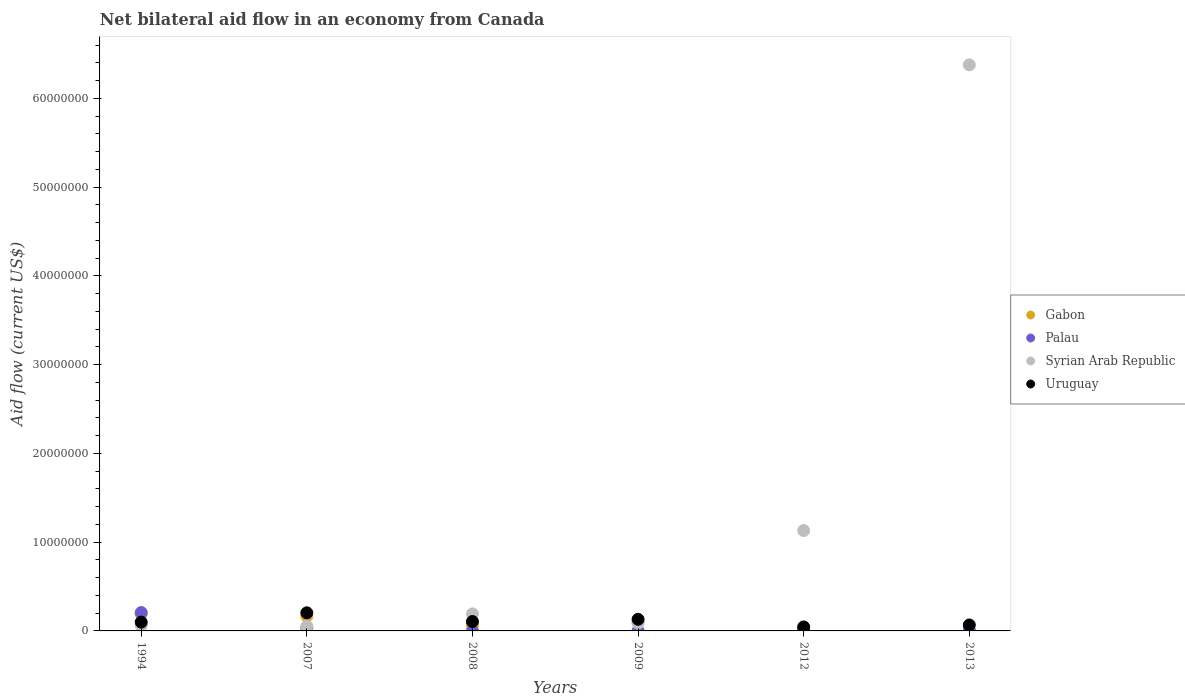How many different coloured dotlines are there?
Provide a succinct answer. 4. Is the number of dotlines equal to the number of legend labels?
Make the answer very short. Yes. What is the net bilateral aid flow in Gabon in 1994?
Your answer should be compact. 1.94e+06. Across all years, what is the maximum net bilateral aid flow in Palau?
Offer a very short reply. 2.07e+06. In which year was the net bilateral aid flow in Gabon maximum?
Offer a terse response. 1994. What is the total net bilateral aid flow in Gabon in the graph?
Offer a very short reply. 5.35e+06. What is the difference between the net bilateral aid flow in Syrian Arab Republic in 2009 and that in 2012?
Keep it short and to the point. -1.04e+07. What is the difference between the net bilateral aid flow in Palau in 1994 and the net bilateral aid flow in Uruguay in 2013?
Offer a very short reply. 1.40e+06. What is the average net bilateral aid flow in Gabon per year?
Your answer should be compact. 8.92e+05. In the year 2007, what is the difference between the net bilateral aid flow in Palau and net bilateral aid flow in Gabon?
Keep it short and to the point. -1.32e+06. What is the ratio of the net bilateral aid flow in Palau in 1994 to that in 2013?
Your response must be concise. 41.4. Is the net bilateral aid flow in Syrian Arab Republic in 1994 less than that in 2009?
Your response must be concise. Yes. Is the difference between the net bilateral aid flow in Palau in 1994 and 2009 greater than the difference between the net bilateral aid flow in Gabon in 1994 and 2009?
Your answer should be compact. Yes. What is the difference between the highest and the second highest net bilateral aid flow in Palau?
Give a very brief answer. 1.73e+06. What is the difference between the highest and the lowest net bilateral aid flow in Syrian Arab Republic?
Make the answer very short. 6.33e+07. Is it the case that in every year, the sum of the net bilateral aid flow in Gabon and net bilateral aid flow in Uruguay  is greater than the sum of net bilateral aid flow in Syrian Arab Republic and net bilateral aid flow in Palau?
Offer a very short reply. No. Does the net bilateral aid flow in Uruguay monotonically increase over the years?
Keep it short and to the point. No. Is the net bilateral aid flow in Syrian Arab Republic strictly greater than the net bilateral aid flow in Gabon over the years?
Offer a very short reply. No. How many dotlines are there?
Make the answer very short. 4. How many years are there in the graph?
Your answer should be very brief. 6. Are the values on the major ticks of Y-axis written in scientific E-notation?
Provide a short and direct response. No. Does the graph contain any zero values?
Your answer should be very brief. No. Where does the legend appear in the graph?
Your response must be concise. Center right. How are the legend labels stacked?
Your answer should be very brief. Vertical. What is the title of the graph?
Ensure brevity in your answer.  Net bilateral aid flow in an economy from Canada. What is the label or title of the Y-axis?
Your answer should be compact. Aid flow (current US$). What is the Aid flow (current US$) in Gabon in 1994?
Keep it short and to the point. 1.94e+06. What is the Aid flow (current US$) in Palau in 1994?
Give a very brief answer. 2.07e+06. What is the Aid flow (current US$) of Syrian Arab Republic in 1994?
Your answer should be compact. 6.20e+05. What is the Aid flow (current US$) in Uruguay in 1994?
Offer a very short reply. 9.90e+05. What is the Aid flow (current US$) of Gabon in 2007?
Provide a succinct answer. 1.66e+06. What is the Aid flow (current US$) in Palau in 2007?
Ensure brevity in your answer.  3.40e+05. What is the Aid flow (current US$) in Syrian Arab Republic in 2007?
Your answer should be very brief. 5.20e+05. What is the Aid flow (current US$) in Uruguay in 2007?
Provide a succinct answer. 2.04e+06. What is the Aid flow (current US$) in Gabon in 2008?
Your answer should be compact. 6.50e+05. What is the Aid flow (current US$) in Palau in 2008?
Your response must be concise. 10000. What is the Aid flow (current US$) of Syrian Arab Republic in 2008?
Your response must be concise. 1.92e+06. What is the Aid flow (current US$) in Uruguay in 2008?
Offer a terse response. 1.06e+06. What is the Aid flow (current US$) of Gabon in 2009?
Offer a very short reply. 9.80e+05. What is the Aid flow (current US$) in Palau in 2009?
Provide a short and direct response. 10000. What is the Aid flow (current US$) of Syrian Arab Republic in 2009?
Offer a very short reply. 8.70e+05. What is the Aid flow (current US$) in Uruguay in 2009?
Keep it short and to the point. 1.31e+06. What is the Aid flow (current US$) of Gabon in 2012?
Provide a short and direct response. 5.00e+04. What is the Aid flow (current US$) in Syrian Arab Republic in 2012?
Keep it short and to the point. 1.13e+07. What is the Aid flow (current US$) of Syrian Arab Republic in 2013?
Provide a succinct answer. 6.38e+07. What is the Aid flow (current US$) of Uruguay in 2013?
Your answer should be compact. 6.70e+05. Across all years, what is the maximum Aid flow (current US$) in Gabon?
Provide a short and direct response. 1.94e+06. Across all years, what is the maximum Aid flow (current US$) of Palau?
Offer a very short reply. 2.07e+06. Across all years, what is the maximum Aid flow (current US$) in Syrian Arab Republic?
Your answer should be very brief. 6.38e+07. Across all years, what is the maximum Aid flow (current US$) in Uruguay?
Your answer should be very brief. 2.04e+06. Across all years, what is the minimum Aid flow (current US$) of Gabon?
Your answer should be compact. 5.00e+04. Across all years, what is the minimum Aid flow (current US$) in Syrian Arab Republic?
Your answer should be very brief. 5.20e+05. Across all years, what is the minimum Aid flow (current US$) of Uruguay?
Your response must be concise. 4.50e+05. What is the total Aid flow (current US$) of Gabon in the graph?
Provide a short and direct response. 5.35e+06. What is the total Aid flow (current US$) of Palau in the graph?
Give a very brief answer. 2.65e+06. What is the total Aid flow (current US$) in Syrian Arab Republic in the graph?
Make the answer very short. 7.90e+07. What is the total Aid flow (current US$) in Uruguay in the graph?
Provide a succinct answer. 6.52e+06. What is the difference between the Aid flow (current US$) of Palau in 1994 and that in 2007?
Give a very brief answer. 1.73e+06. What is the difference between the Aid flow (current US$) in Uruguay in 1994 and that in 2007?
Provide a short and direct response. -1.05e+06. What is the difference between the Aid flow (current US$) in Gabon in 1994 and that in 2008?
Keep it short and to the point. 1.29e+06. What is the difference between the Aid flow (current US$) in Palau in 1994 and that in 2008?
Your response must be concise. 2.06e+06. What is the difference between the Aid flow (current US$) in Syrian Arab Republic in 1994 and that in 2008?
Your answer should be compact. -1.30e+06. What is the difference between the Aid flow (current US$) in Gabon in 1994 and that in 2009?
Give a very brief answer. 9.60e+05. What is the difference between the Aid flow (current US$) of Palau in 1994 and that in 2009?
Your answer should be compact. 2.06e+06. What is the difference between the Aid flow (current US$) in Uruguay in 1994 and that in 2009?
Your answer should be compact. -3.20e+05. What is the difference between the Aid flow (current US$) of Gabon in 1994 and that in 2012?
Offer a very short reply. 1.89e+06. What is the difference between the Aid flow (current US$) of Palau in 1994 and that in 2012?
Ensure brevity in your answer.  1.90e+06. What is the difference between the Aid flow (current US$) of Syrian Arab Republic in 1994 and that in 2012?
Keep it short and to the point. -1.07e+07. What is the difference between the Aid flow (current US$) in Uruguay in 1994 and that in 2012?
Ensure brevity in your answer.  5.40e+05. What is the difference between the Aid flow (current US$) in Gabon in 1994 and that in 2013?
Your response must be concise. 1.87e+06. What is the difference between the Aid flow (current US$) of Palau in 1994 and that in 2013?
Offer a terse response. 2.02e+06. What is the difference between the Aid flow (current US$) of Syrian Arab Republic in 1994 and that in 2013?
Offer a very short reply. -6.32e+07. What is the difference between the Aid flow (current US$) in Uruguay in 1994 and that in 2013?
Your answer should be compact. 3.20e+05. What is the difference between the Aid flow (current US$) in Gabon in 2007 and that in 2008?
Your answer should be very brief. 1.01e+06. What is the difference between the Aid flow (current US$) in Palau in 2007 and that in 2008?
Offer a very short reply. 3.30e+05. What is the difference between the Aid flow (current US$) in Syrian Arab Republic in 2007 and that in 2008?
Give a very brief answer. -1.40e+06. What is the difference between the Aid flow (current US$) in Uruguay in 2007 and that in 2008?
Make the answer very short. 9.80e+05. What is the difference between the Aid flow (current US$) in Gabon in 2007 and that in 2009?
Ensure brevity in your answer.  6.80e+05. What is the difference between the Aid flow (current US$) of Palau in 2007 and that in 2009?
Ensure brevity in your answer.  3.30e+05. What is the difference between the Aid flow (current US$) in Syrian Arab Republic in 2007 and that in 2009?
Your response must be concise. -3.50e+05. What is the difference between the Aid flow (current US$) of Uruguay in 2007 and that in 2009?
Your response must be concise. 7.30e+05. What is the difference between the Aid flow (current US$) in Gabon in 2007 and that in 2012?
Your response must be concise. 1.61e+06. What is the difference between the Aid flow (current US$) in Syrian Arab Republic in 2007 and that in 2012?
Give a very brief answer. -1.08e+07. What is the difference between the Aid flow (current US$) in Uruguay in 2007 and that in 2012?
Your response must be concise. 1.59e+06. What is the difference between the Aid flow (current US$) of Gabon in 2007 and that in 2013?
Provide a short and direct response. 1.59e+06. What is the difference between the Aid flow (current US$) of Palau in 2007 and that in 2013?
Provide a succinct answer. 2.90e+05. What is the difference between the Aid flow (current US$) in Syrian Arab Republic in 2007 and that in 2013?
Keep it short and to the point. -6.33e+07. What is the difference between the Aid flow (current US$) of Uruguay in 2007 and that in 2013?
Offer a very short reply. 1.37e+06. What is the difference between the Aid flow (current US$) of Gabon in 2008 and that in 2009?
Your answer should be compact. -3.30e+05. What is the difference between the Aid flow (current US$) in Syrian Arab Republic in 2008 and that in 2009?
Provide a short and direct response. 1.05e+06. What is the difference between the Aid flow (current US$) in Uruguay in 2008 and that in 2009?
Keep it short and to the point. -2.50e+05. What is the difference between the Aid flow (current US$) of Gabon in 2008 and that in 2012?
Give a very brief answer. 6.00e+05. What is the difference between the Aid flow (current US$) in Syrian Arab Republic in 2008 and that in 2012?
Offer a very short reply. -9.39e+06. What is the difference between the Aid flow (current US$) of Gabon in 2008 and that in 2013?
Your answer should be very brief. 5.80e+05. What is the difference between the Aid flow (current US$) in Syrian Arab Republic in 2008 and that in 2013?
Your response must be concise. -6.19e+07. What is the difference between the Aid flow (current US$) in Uruguay in 2008 and that in 2013?
Ensure brevity in your answer.  3.90e+05. What is the difference between the Aid flow (current US$) in Gabon in 2009 and that in 2012?
Your response must be concise. 9.30e+05. What is the difference between the Aid flow (current US$) in Palau in 2009 and that in 2012?
Offer a very short reply. -1.60e+05. What is the difference between the Aid flow (current US$) of Syrian Arab Republic in 2009 and that in 2012?
Give a very brief answer. -1.04e+07. What is the difference between the Aid flow (current US$) of Uruguay in 2009 and that in 2012?
Provide a succinct answer. 8.60e+05. What is the difference between the Aid flow (current US$) in Gabon in 2009 and that in 2013?
Offer a very short reply. 9.10e+05. What is the difference between the Aid flow (current US$) in Syrian Arab Republic in 2009 and that in 2013?
Your answer should be compact. -6.29e+07. What is the difference between the Aid flow (current US$) of Uruguay in 2009 and that in 2013?
Offer a very short reply. 6.40e+05. What is the difference between the Aid flow (current US$) in Syrian Arab Republic in 2012 and that in 2013?
Provide a short and direct response. -5.25e+07. What is the difference between the Aid flow (current US$) in Uruguay in 2012 and that in 2013?
Your answer should be very brief. -2.20e+05. What is the difference between the Aid flow (current US$) of Gabon in 1994 and the Aid flow (current US$) of Palau in 2007?
Your answer should be very brief. 1.60e+06. What is the difference between the Aid flow (current US$) in Gabon in 1994 and the Aid flow (current US$) in Syrian Arab Republic in 2007?
Offer a very short reply. 1.42e+06. What is the difference between the Aid flow (current US$) in Palau in 1994 and the Aid flow (current US$) in Syrian Arab Republic in 2007?
Offer a very short reply. 1.55e+06. What is the difference between the Aid flow (current US$) of Syrian Arab Republic in 1994 and the Aid flow (current US$) of Uruguay in 2007?
Provide a succinct answer. -1.42e+06. What is the difference between the Aid flow (current US$) of Gabon in 1994 and the Aid flow (current US$) of Palau in 2008?
Give a very brief answer. 1.93e+06. What is the difference between the Aid flow (current US$) in Gabon in 1994 and the Aid flow (current US$) in Syrian Arab Republic in 2008?
Make the answer very short. 2.00e+04. What is the difference between the Aid flow (current US$) in Gabon in 1994 and the Aid flow (current US$) in Uruguay in 2008?
Your response must be concise. 8.80e+05. What is the difference between the Aid flow (current US$) of Palau in 1994 and the Aid flow (current US$) of Uruguay in 2008?
Your response must be concise. 1.01e+06. What is the difference between the Aid flow (current US$) of Syrian Arab Republic in 1994 and the Aid flow (current US$) of Uruguay in 2008?
Give a very brief answer. -4.40e+05. What is the difference between the Aid flow (current US$) in Gabon in 1994 and the Aid flow (current US$) in Palau in 2009?
Your answer should be very brief. 1.93e+06. What is the difference between the Aid flow (current US$) of Gabon in 1994 and the Aid flow (current US$) of Syrian Arab Republic in 2009?
Your answer should be compact. 1.07e+06. What is the difference between the Aid flow (current US$) of Gabon in 1994 and the Aid flow (current US$) of Uruguay in 2009?
Keep it short and to the point. 6.30e+05. What is the difference between the Aid flow (current US$) in Palau in 1994 and the Aid flow (current US$) in Syrian Arab Republic in 2009?
Keep it short and to the point. 1.20e+06. What is the difference between the Aid flow (current US$) in Palau in 1994 and the Aid flow (current US$) in Uruguay in 2009?
Your answer should be very brief. 7.60e+05. What is the difference between the Aid flow (current US$) in Syrian Arab Republic in 1994 and the Aid flow (current US$) in Uruguay in 2009?
Make the answer very short. -6.90e+05. What is the difference between the Aid flow (current US$) of Gabon in 1994 and the Aid flow (current US$) of Palau in 2012?
Provide a succinct answer. 1.77e+06. What is the difference between the Aid flow (current US$) of Gabon in 1994 and the Aid flow (current US$) of Syrian Arab Republic in 2012?
Offer a terse response. -9.37e+06. What is the difference between the Aid flow (current US$) in Gabon in 1994 and the Aid flow (current US$) in Uruguay in 2012?
Make the answer very short. 1.49e+06. What is the difference between the Aid flow (current US$) in Palau in 1994 and the Aid flow (current US$) in Syrian Arab Republic in 2012?
Make the answer very short. -9.24e+06. What is the difference between the Aid flow (current US$) in Palau in 1994 and the Aid flow (current US$) in Uruguay in 2012?
Provide a succinct answer. 1.62e+06. What is the difference between the Aid flow (current US$) of Gabon in 1994 and the Aid flow (current US$) of Palau in 2013?
Ensure brevity in your answer.  1.89e+06. What is the difference between the Aid flow (current US$) in Gabon in 1994 and the Aid flow (current US$) in Syrian Arab Republic in 2013?
Your answer should be very brief. -6.18e+07. What is the difference between the Aid flow (current US$) of Gabon in 1994 and the Aid flow (current US$) of Uruguay in 2013?
Keep it short and to the point. 1.27e+06. What is the difference between the Aid flow (current US$) of Palau in 1994 and the Aid flow (current US$) of Syrian Arab Republic in 2013?
Offer a terse response. -6.17e+07. What is the difference between the Aid flow (current US$) of Palau in 1994 and the Aid flow (current US$) of Uruguay in 2013?
Keep it short and to the point. 1.40e+06. What is the difference between the Aid flow (current US$) of Gabon in 2007 and the Aid flow (current US$) of Palau in 2008?
Your answer should be compact. 1.65e+06. What is the difference between the Aid flow (current US$) in Gabon in 2007 and the Aid flow (current US$) in Syrian Arab Republic in 2008?
Your response must be concise. -2.60e+05. What is the difference between the Aid flow (current US$) in Palau in 2007 and the Aid flow (current US$) in Syrian Arab Republic in 2008?
Offer a very short reply. -1.58e+06. What is the difference between the Aid flow (current US$) in Palau in 2007 and the Aid flow (current US$) in Uruguay in 2008?
Offer a very short reply. -7.20e+05. What is the difference between the Aid flow (current US$) in Syrian Arab Republic in 2007 and the Aid flow (current US$) in Uruguay in 2008?
Your answer should be very brief. -5.40e+05. What is the difference between the Aid flow (current US$) of Gabon in 2007 and the Aid flow (current US$) of Palau in 2009?
Provide a succinct answer. 1.65e+06. What is the difference between the Aid flow (current US$) of Gabon in 2007 and the Aid flow (current US$) of Syrian Arab Republic in 2009?
Provide a short and direct response. 7.90e+05. What is the difference between the Aid flow (current US$) in Gabon in 2007 and the Aid flow (current US$) in Uruguay in 2009?
Make the answer very short. 3.50e+05. What is the difference between the Aid flow (current US$) in Palau in 2007 and the Aid flow (current US$) in Syrian Arab Republic in 2009?
Provide a short and direct response. -5.30e+05. What is the difference between the Aid flow (current US$) of Palau in 2007 and the Aid flow (current US$) of Uruguay in 2009?
Give a very brief answer. -9.70e+05. What is the difference between the Aid flow (current US$) in Syrian Arab Republic in 2007 and the Aid flow (current US$) in Uruguay in 2009?
Make the answer very short. -7.90e+05. What is the difference between the Aid flow (current US$) of Gabon in 2007 and the Aid flow (current US$) of Palau in 2012?
Offer a very short reply. 1.49e+06. What is the difference between the Aid flow (current US$) of Gabon in 2007 and the Aid flow (current US$) of Syrian Arab Republic in 2012?
Give a very brief answer. -9.65e+06. What is the difference between the Aid flow (current US$) of Gabon in 2007 and the Aid flow (current US$) of Uruguay in 2012?
Ensure brevity in your answer.  1.21e+06. What is the difference between the Aid flow (current US$) of Palau in 2007 and the Aid flow (current US$) of Syrian Arab Republic in 2012?
Your response must be concise. -1.10e+07. What is the difference between the Aid flow (current US$) of Palau in 2007 and the Aid flow (current US$) of Uruguay in 2012?
Your answer should be very brief. -1.10e+05. What is the difference between the Aid flow (current US$) in Syrian Arab Republic in 2007 and the Aid flow (current US$) in Uruguay in 2012?
Ensure brevity in your answer.  7.00e+04. What is the difference between the Aid flow (current US$) of Gabon in 2007 and the Aid flow (current US$) of Palau in 2013?
Make the answer very short. 1.61e+06. What is the difference between the Aid flow (current US$) in Gabon in 2007 and the Aid flow (current US$) in Syrian Arab Republic in 2013?
Provide a succinct answer. -6.21e+07. What is the difference between the Aid flow (current US$) of Gabon in 2007 and the Aid flow (current US$) of Uruguay in 2013?
Provide a short and direct response. 9.90e+05. What is the difference between the Aid flow (current US$) in Palau in 2007 and the Aid flow (current US$) in Syrian Arab Republic in 2013?
Give a very brief answer. -6.34e+07. What is the difference between the Aid flow (current US$) of Palau in 2007 and the Aid flow (current US$) of Uruguay in 2013?
Ensure brevity in your answer.  -3.30e+05. What is the difference between the Aid flow (current US$) of Syrian Arab Republic in 2007 and the Aid flow (current US$) of Uruguay in 2013?
Give a very brief answer. -1.50e+05. What is the difference between the Aid flow (current US$) in Gabon in 2008 and the Aid flow (current US$) in Palau in 2009?
Your response must be concise. 6.40e+05. What is the difference between the Aid flow (current US$) in Gabon in 2008 and the Aid flow (current US$) in Uruguay in 2009?
Keep it short and to the point. -6.60e+05. What is the difference between the Aid flow (current US$) in Palau in 2008 and the Aid flow (current US$) in Syrian Arab Republic in 2009?
Keep it short and to the point. -8.60e+05. What is the difference between the Aid flow (current US$) in Palau in 2008 and the Aid flow (current US$) in Uruguay in 2009?
Ensure brevity in your answer.  -1.30e+06. What is the difference between the Aid flow (current US$) of Gabon in 2008 and the Aid flow (current US$) of Syrian Arab Republic in 2012?
Make the answer very short. -1.07e+07. What is the difference between the Aid flow (current US$) in Gabon in 2008 and the Aid flow (current US$) in Uruguay in 2012?
Your answer should be compact. 2.00e+05. What is the difference between the Aid flow (current US$) of Palau in 2008 and the Aid flow (current US$) of Syrian Arab Republic in 2012?
Make the answer very short. -1.13e+07. What is the difference between the Aid flow (current US$) in Palau in 2008 and the Aid flow (current US$) in Uruguay in 2012?
Provide a short and direct response. -4.40e+05. What is the difference between the Aid flow (current US$) in Syrian Arab Republic in 2008 and the Aid flow (current US$) in Uruguay in 2012?
Provide a short and direct response. 1.47e+06. What is the difference between the Aid flow (current US$) of Gabon in 2008 and the Aid flow (current US$) of Palau in 2013?
Your response must be concise. 6.00e+05. What is the difference between the Aid flow (current US$) of Gabon in 2008 and the Aid flow (current US$) of Syrian Arab Republic in 2013?
Your answer should be compact. -6.31e+07. What is the difference between the Aid flow (current US$) in Palau in 2008 and the Aid flow (current US$) in Syrian Arab Republic in 2013?
Keep it short and to the point. -6.38e+07. What is the difference between the Aid flow (current US$) of Palau in 2008 and the Aid flow (current US$) of Uruguay in 2013?
Your answer should be very brief. -6.60e+05. What is the difference between the Aid flow (current US$) of Syrian Arab Republic in 2008 and the Aid flow (current US$) of Uruguay in 2013?
Your answer should be compact. 1.25e+06. What is the difference between the Aid flow (current US$) in Gabon in 2009 and the Aid flow (current US$) in Palau in 2012?
Provide a short and direct response. 8.10e+05. What is the difference between the Aid flow (current US$) of Gabon in 2009 and the Aid flow (current US$) of Syrian Arab Republic in 2012?
Offer a very short reply. -1.03e+07. What is the difference between the Aid flow (current US$) of Gabon in 2009 and the Aid flow (current US$) of Uruguay in 2012?
Your answer should be compact. 5.30e+05. What is the difference between the Aid flow (current US$) of Palau in 2009 and the Aid flow (current US$) of Syrian Arab Republic in 2012?
Provide a short and direct response. -1.13e+07. What is the difference between the Aid flow (current US$) in Palau in 2009 and the Aid flow (current US$) in Uruguay in 2012?
Give a very brief answer. -4.40e+05. What is the difference between the Aid flow (current US$) of Syrian Arab Republic in 2009 and the Aid flow (current US$) of Uruguay in 2012?
Provide a short and direct response. 4.20e+05. What is the difference between the Aid flow (current US$) of Gabon in 2009 and the Aid flow (current US$) of Palau in 2013?
Provide a short and direct response. 9.30e+05. What is the difference between the Aid flow (current US$) of Gabon in 2009 and the Aid flow (current US$) of Syrian Arab Republic in 2013?
Your response must be concise. -6.28e+07. What is the difference between the Aid flow (current US$) in Gabon in 2009 and the Aid flow (current US$) in Uruguay in 2013?
Provide a succinct answer. 3.10e+05. What is the difference between the Aid flow (current US$) in Palau in 2009 and the Aid flow (current US$) in Syrian Arab Republic in 2013?
Your answer should be compact. -6.38e+07. What is the difference between the Aid flow (current US$) in Palau in 2009 and the Aid flow (current US$) in Uruguay in 2013?
Provide a short and direct response. -6.60e+05. What is the difference between the Aid flow (current US$) in Syrian Arab Republic in 2009 and the Aid flow (current US$) in Uruguay in 2013?
Give a very brief answer. 2.00e+05. What is the difference between the Aid flow (current US$) of Gabon in 2012 and the Aid flow (current US$) of Palau in 2013?
Keep it short and to the point. 0. What is the difference between the Aid flow (current US$) of Gabon in 2012 and the Aid flow (current US$) of Syrian Arab Republic in 2013?
Give a very brief answer. -6.37e+07. What is the difference between the Aid flow (current US$) of Gabon in 2012 and the Aid flow (current US$) of Uruguay in 2013?
Your answer should be very brief. -6.20e+05. What is the difference between the Aid flow (current US$) in Palau in 2012 and the Aid flow (current US$) in Syrian Arab Republic in 2013?
Your answer should be very brief. -6.36e+07. What is the difference between the Aid flow (current US$) in Palau in 2012 and the Aid flow (current US$) in Uruguay in 2013?
Offer a terse response. -5.00e+05. What is the difference between the Aid flow (current US$) in Syrian Arab Republic in 2012 and the Aid flow (current US$) in Uruguay in 2013?
Ensure brevity in your answer.  1.06e+07. What is the average Aid flow (current US$) in Gabon per year?
Keep it short and to the point. 8.92e+05. What is the average Aid flow (current US$) in Palau per year?
Your response must be concise. 4.42e+05. What is the average Aid flow (current US$) in Syrian Arab Republic per year?
Offer a very short reply. 1.32e+07. What is the average Aid flow (current US$) in Uruguay per year?
Give a very brief answer. 1.09e+06. In the year 1994, what is the difference between the Aid flow (current US$) of Gabon and Aid flow (current US$) of Syrian Arab Republic?
Your answer should be compact. 1.32e+06. In the year 1994, what is the difference between the Aid flow (current US$) in Gabon and Aid flow (current US$) in Uruguay?
Give a very brief answer. 9.50e+05. In the year 1994, what is the difference between the Aid flow (current US$) in Palau and Aid flow (current US$) in Syrian Arab Republic?
Provide a succinct answer. 1.45e+06. In the year 1994, what is the difference between the Aid flow (current US$) in Palau and Aid flow (current US$) in Uruguay?
Keep it short and to the point. 1.08e+06. In the year 1994, what is the difference between the Aid flow (current US$) in Syrian Arab Republic and Aid flow (current US$) in Uruguay?
Your answer should be compact. -3.70e+05. In the year 2007, what is the difference between the Aid flow (current US$) of Gabon and Aid flow (current US$) of Palau?
Offer a terse response. 1.32e+06. In the year 2007, what is the difference between the Aid flow (current US$) in Gabon and Aid flow (current US$) in Syrian Arab Republic?
Make the answer very short. 1.14e+06. In the year 2007, what is the difference between the Aid flow (current US$) of Gabon and Aid flow (current US$) of Uruguay?
Ensure brevity in your answer.  -3.80e+05. In the year 2007, what is the difference between the Aid flow (current US$) of Palau and Aid flow (current US$) of Uruguay?
Ensure brevity in your answer.  -1.70e+06. In the year 2007, what is the difference between the Aid flow (current US$) of Syrian Arab Republic and Aid flow (current US$) of Uruguay?
Offer a very short reply. -1.52e+06. In the year 2008, what is the difference between the Aid flow (current US$) of Gabon and Aid flow (current US$) of Palau?
Provide a succinct answer. 6.40e+05. In the year 2008, what is the difference between the Aid flow (current US$) of Gabon and Aid flow (current US$) of Syrian Arab Republic?
Provide a short and direct response. -1.27e+06. In the year 2008, what is the difference between the Aid flow (current US$) in Gabon and Aid flow (current US$) in Uruguay?
Keep it short and to the point. -4.10e+05. In the year 2008, what is the difference between the Aid flow (current US$) in Palau and Aid flow (current US$) in Syrian Arab Republic?
Provide a short and direct response. -1.91e+06. In the year 2008, what is the difference between the Aid flow (current US$) of Palau and Aid flow (current US$) of Uruguay?
Your response must be concise. -1.05e+06. In the year 2008, what is the difference between the Aid flow (current US$) of Syrian Arab Republic and Aid flow (current US$) of Uruguay?
Provide a short and direct response. 8.60e+05. In the year 2009, what is the difference between the Aid flow (current US$) of Gabon and Aid flow (current US$) of Palau?
Ensure brevity in your answer.  9.70e+05. In the year 2009, what is the difference between the Aid flow (current US$) in Gabon and Aid flow (current US$) in Uruguay?
Ensure brevity in your answer.  -3.30e+05. In the year 2009, what is the difference between the Aid flow (current US$) in Palau and Aid flow (current US$) in Syrian Arab Republic?
Provide a short and direct response. -8.60e+05. In the year 2009, what is the difference between the Aid flow (current US$) in Palau and Aid flow (current US$) in Uruguay?
Your answer should be compact. -1.30e+06. In the year 2009, what is the difference between the Aid flow (current US$) in Syrian Arab Republic and Aid flow (current US$) in Uruguay?
Your response must be concise. -4.40e+05. In the year 2012, what is the difference between the Aid flow (current US$) of Gabon and Aid flow (current US$) of Syrian Arab Republic?
Offer a terse response. -1.13e+07. In the year 2012, what is the difference between the Aid flow (current US$) in Gabon and Aid flow (current US$) in Uruguay?
Keep it short and to the point. -4.00e+05. In the year 2012, what is the difference between the Aid flow (current US$) in Palau and Aid flow (current US$) in Syrian Arab Republic?
Your answer should be very brief. -1.11e+07. In the year 2012, what is the difference between the Aid flow (current US$) of Palau and Aid flow (current US$) of Uruguay?
Keep it short and to the point. -2.80e+05. In the year 2012, what is the difference between the Aid flow (current US$) of Syrian Arab Republic and Aid flow (current US$) of Uruguay?
Your answer should be compact. 1.09e+07. In the year 2013, what is the difference between the Aid flow (current US$) of Gabon and Aid flow (current US$) of Palau?
Give a very brief answer. 2.00e+04. In the year 2013, what is the difference between the Aid flow (current US$) in Gabon and Aid flow (current US$) in Syrian Arab Republic?
Your answer should be very brief. -6.37e+07. In the year 2013, what is the difference between the Aid flow (current US$) of Gabon and Aid flow (current US$) of Uruguay?
Offer a terse response. -6.00e+05. In the year 2013, what is the difference between the Aid flow (current US$) of Palau and Aid flow (current US$) of Syrian Arab Republic?
Give a very brief answer. -6.37e+07. In the year 2013, what is the difference between the Aid flow (current US$) of Palau and Aid flow (current US$) of Uruguay?
Ensure brevity in your answer.  -6.20e+05. In the year 2013, what is the difference between the Aid flow (current US$) of Syrian Arab Republic and Aid flow (current US$) of Uruguay?
Offer a very short reply. 6.31e+07. What is the ratio of the Aid flow (current US$) in Gabon in 1994 to that in 2007?
Make the answer very short. 1.17. What is the ratio of the Aid flow (current US$) of Palau in 1994 to that in 2007?
Make the answer very short. 6.09. What is the ratio of the Aid flow (current US$) in Syrian Arab Republic in 1994 to that in 2007?
Provide a succinct answer. 1.19. What is the ratio of the Aid flow (current US$) in Uruguay in 1994 to that in 2007?
Keep it short and to the point. 0.49. What is the ratio of the Aid flow (current US$) in Gabon in 1994 to that in 2008?
Keep it short and to the point. 2.98. What is the ratio of the Aid flow (current US$) in Palau in 1994 to that in 2008?
Ensure brevity in your answer.  207. What is the ratio of the Aid flow (current US$) in Syrian Arab Republic in 1994 to that in 2008?
Provide a short and direct response. 0.32. What is the ratio of the Aid flow (current US$) of Uruguay in 1994 to that in 2008?
Keep it short and to the point. 0.93. What is the ratio of the Aid flow (current US$) of Gabon in 1994 to that in 2009?
Make the answer very short. 1.98. What is the ratio of the Aid flow (current US$) of Palau in 1994 to that in 2009?
Make the answer very short. 207. What is the ratio of the Aid flow (current US$) of Syrian Arab Republic in 1994 to that in 2009?
Your answer should be very brief. 0.71. What is the ratio of the Aid flow (current US$) in Uruguay in 1994 to that in 2009?
Keep it short and to the point. 0.76. What is the ratio of the Aid flow (current US$) in Gabon in 1994 to that in 2012?
Your response must be concise. 38.8. What is the ratio of the Aid flow (current US$) in Palau in 1994 to that in 2012?
Your answer should be compact. 12.18. What is the ratio of the Aid flow (current US$) of Syrian Arab Republic in 1994 to that in 2012?
Make the answer very short. 0.05. What is the ratio of the Aid flow (current US$) in Uruguay in 1994 to that in 2012?
Keep it short and to the point. 2.2. What is the ratio of the Aid flow (current US$) in Gabon in 1994 to that in 2013?
Your answer should be compact. 27.71. What is the ratio of the Aid flow (current US$) of Palau in 1994 to that in 2013?
Offer a terse response. 41.4. What is the ratio of the Aid flow (current US$) of Syrian Arab Republic in 1994 to that in 2013?
Give a very brief answer. 0.01. What is the ratio of the Aid flow (current US$) of Uruguay in 1994 to that in 2013?
Your answer should be very brief. 1.48. What is the ratio of the Aid flow (current US$) in Gabon in 2007 to that in 2008?
Your response must be concise. 2.55. What is the ratio of the Aid flow (current US$) of Syrian Arab Republic in 2007 to that in 2008?
Your answer should be very brief. 0.27. What is the ratio of the Aid flow (current US$) of Uruguay in 2007 to that in 2008?
Ensure brevity in your answer.  1.92. What is the ratio of the Aid flow (current US$) in Gabon in 2007 to that in 2009?
Provide a succinct answer. 1.69. What is the ratio of the Aid flow (current US$) of Syrian Arab Republic in 2007 to that in 2009?
Keep it short and to the point. 0.6. What is the ratio of the Aid flow (current US$) in Uruguay in 2007 to that in 2009?
Provide a short and direct response. 1.56. What is the ratio of the Aid flow (current US$) of Gabon in 2007 to that in 2012?
Provide a succinct answer. 33.2. What is the ratio of the Aid flow (current US$) of Palau in 2007 to that in 2012?
Keep it short and to the point. 2. What is the ratio of the Aid flow (current US$) of Syrian Arab Republic in 2007 to that in 2012?
Provide a short and direct response. 0.05. What is the ratio of the Aid flow (current US$) in Uruguay in 2007 to that in 2012?
Offer a very short reply. 4.53. What is the ratio of the Aid flow (current US$) in Gabon in 2007 to that in 2013?
Provide a succinct answer. 23.71. What is the ratio of the Aid flow (current US$) of Syrian Arab Republic in 2007 to that in 2013?
Offer a very short reply. 0.01. What is the ratio of the Aid flow (current US$) of Uruguay in 2007 to that in 2013?
Provide a short and direct response. 3.04. What is the ratio of the Aid flow (current US$) of Gabon in 2008 to that in 2009?
Give a very brief answer. 0.66. What is the ratio of the Aid flow (current US$) in Syrian Arab Republic in 2008 to that in 2009?
Provide a succinct answer. 2.21. What is the ratio of the Aid flow (current US$) in Uruguay in 2008 to that in 2009?
Keep it short and to the point. 0.81. What is the ratio of the Aid flow (current US$) in Gabon in 2008 to that in 2012?
Offer a very short reply. 13. What is the ratio of the Aid flow (current US$) of Palau in 2008 to that in 2012?
Your response must be concise. 0.06. What is the ratio of the Aid flow (current US$) of Syrian Arab Republic in 2008 to that in 2012?
Keep it short and to the point. 0.17. What is the ratio of the Aid flow (current US$) of Uruguay in 2008 to that in 2012?
Your answer should be very brief. 2.36. What is the ratio of the Aid flow (current US$) in Gabon in 2008 to that in 2013?
Offer a very short reply. 9.29. What is the ratio of the Aid flow (current US$) in Syrian Arab Republic in 2008 to that in 2013?
Offer a very short reply. 0.03. What is the ratio of the Aid flow (current US$) of Uruguay in 2008 to that in 2013?
Make the answer very short. 1.58. What is the ratio of the Aid flow (current US$) in Gabon in 2009 to that in 2012?
Ensure brevity in your answer.  19.6. What is the ratio of the Aid flow (current US$) in Palau in 2009 to that in 2012?
Make the answer very short. 0.06. What is the ratio of the Aid flow (current US$) in Syrian Arab Republic in 2009 to that in 2012?
Provide a short and direct response. 0.08. What is the ratio of the Aid flow (current US$) in Uruguay in 2009 to that in 2012?
Offer a very short reply. 2.91. What is the ratio of the Aid flow (current US$) of Syrian Arab Republic in 2009 to that in 2013?
Ensure brevity in your answer.  0.01. What is the ratio of the Aid flow (current US$) of Uruguay in 2009 to that in 2013?
Make the answer very short. 1.96. What is the ratio of the Aid flow (current US$) of Syrian Arab Republic in 2012 to that in 2013?
Provide a succinct answer. 0.18. What is the ratio of the Aid flow (current US$) in Uruguay in 2012 to that in 2013?
Provide a succinct answer. 0.67. What is the difference between the highest and the second highest Aid flow (current US$) of Gabon?
Ensure brevity in your answer.  2.80e+05. What is the difference between the highest and the second highest Aid flow (current US$) of Palau?
Your response must be concise. 1.73e+06. What is the difference between the highest and the second highest Aid flow (current US$) in Syrian Arab Republic?
Ensure brevity in your answer.  5.25e+07. What is the difference between the highest and the second highest Aid flow (current US$) in Uruguay?
Provide a succinct answer. 7.30e+05. What is the difference between the highest and the lowest Aid flow (current US$) in Gabon?
Keep it short and to the point. 1.89e+06. What is the difference between the highest and the lowest Aid flow (current US$) of Palau?
Offer a terse response. 2.06e+06. What is the difference between the highest and the lowest Aid flow (current US$) of Syrian Arab Republic?
Provide a succinct answer. 6.33e+07. What is the difference between the highest and the lowest Aid flow (current US$) in Uruguay?
Offer a terse response. 1.59e+06. 